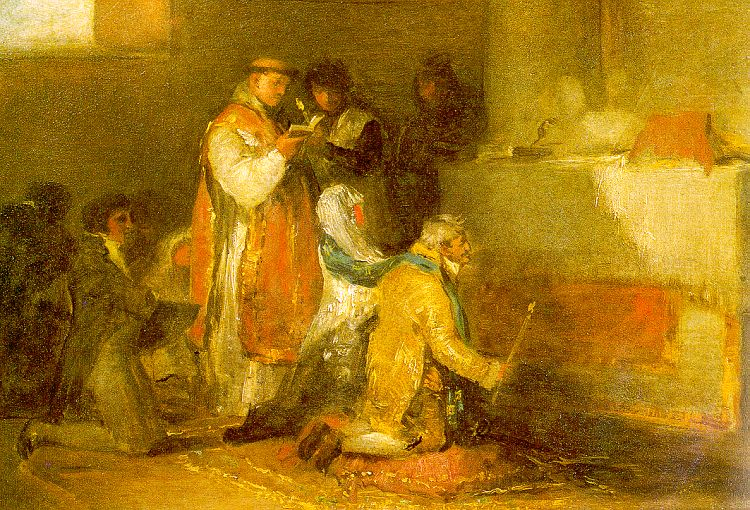What does the lighting and color scheme in the painting suggest about the mood and setting of the scene? The lighting in the painting is warm and soft, primarily focusing on the central group of figures, which helps in drawing viewers' attention to them. The use of warm earth tones like browns, yellows, and oranges, alongside the subtle interplay of light and shadows, creates a cozy and inviting atmosphere. This suggests the scene is set in an intimate indoor setting, possibly during the evening. The mood is contemplative and serene, reflecting a moment captured in daily life where the characters are engrossed in a calm yet engaging activity. 